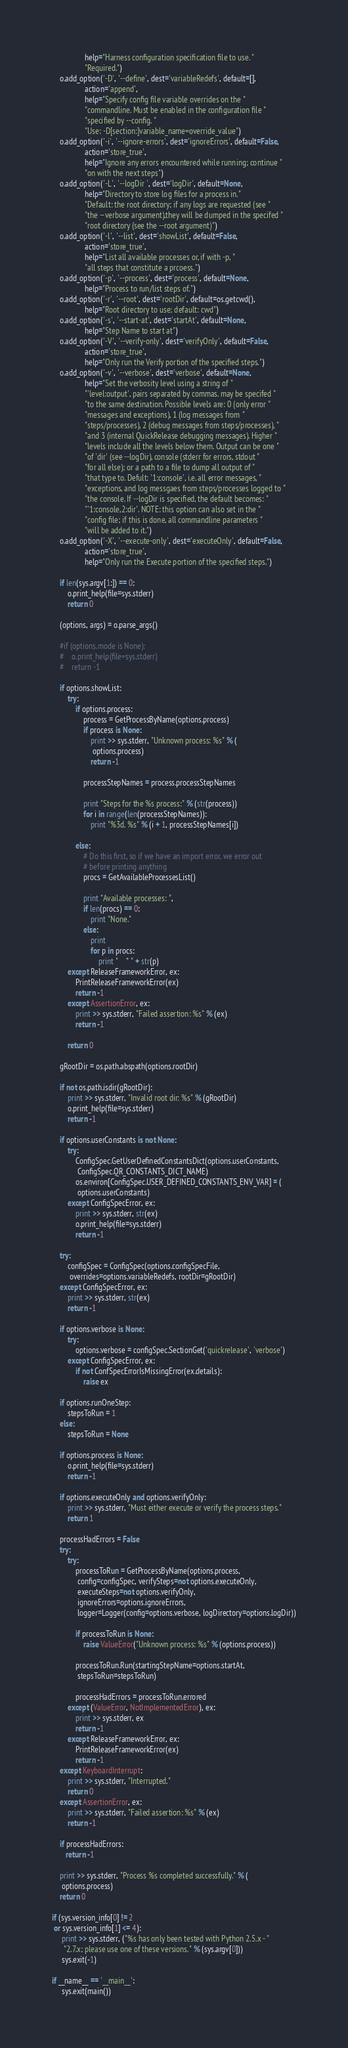Convert code to text. <code><loc_0><loc_0><loc_500><loc_500><_Python_>                 help="Harness configuration specification file to use. "
                 "Required.")
    o.add_option('-D', '--define', dest='variableRedefs', default=[],
                 action='append',
                 help="Specify config file variable overrides on the "
                 "commandline. Must be enabled in the configuration file "
                 "specified by --config. "
                 "Use: -D[section:]variable_name=override_value")
    o.add_option('-i', '--ignore-errors', dest='ignoreErrors', default=False,
                 action='store_true',
                 help="Ignore any errors encountered while running; continue "
                 "on with the next steps")
    o.add_option('-L', '--logDir ', dest='logDir', default=None,
                 help="Directory to store log files for a process in."
                 "Default: the root directory; if any logs are requested (see "
                 "the --verbose argument),they will be dumped in the specifed "
                 "root directory (see the --root argument)")
    o.add_option('-l', '--list', dest='showList', default=False,
                 action='store_true',
                 help="List all available processes or, if with -p, "
                 "all steps that constitute a prcoess.")
    o.add_option('-p', '--process', dest='process', default=None,
                 help="Process to run/list steps of.")
    o.add_option('-r', '--root', dest='rootDir', default=os.getcwd(),
                 help="Root directory to use; default: cwd")
    o.add_option('-s', '--start-at', dest='startAt', default=None,
                 help="Step Name to start at")
    o.add_option('-V', '--verify-only', dest='verifyOnly', default=False,
                 action='store_true',
                 help="Only run the Verify portion of the specified steps.")
    o.add_option('-v', '--verbose', dest='verbose', default=None,
                 help="Set the verbosity level using a string of "
                 "'level:output', pairs separated by commas. may be specifed "
                 "to the same destination. Possible levels are: 0 (only error "
                 "messages and exceptions), 1 (log messages from "
                 "steps/processes), 2 (debug messages from steps/processes), "
                 "and 3 (internal QuickRelease debugging messages). Higher "
                 "levels include all the levels below them. Output can be one "
                 "of 'dir' (see --logDir), console (stderr for errors, stdout "
                 "for all else); or a path to a file to dump all output of "
                 "that type to. Defult: '1:console', i.e. all error messages, "
                 "exceptions, and log messgaes from steps/processes logged to "
                 "the console. If --logDir is specified, the default becomes: "
                 "'1:console,2:dir'. NOTE: this option can also set in the "
                 "config file; if this is done, all commandline parameters "
                 "will be added to it.")
    o.add_option('-X', '--execute-only', dest='executeOnly', default=False,
                 action='store_true',
                 help="Only run the Execute portion of the specified steps.")

    if len(sys.argv[1:]) == 0:
        o.print_help(file=sys.stderr)
        return 0

    (options, args) = o.parse_args()

    #if (options.mode is None):
    #    o.print_help(file=sys.stderr)
    #    return -1

    if options.showList:
        try:
            if options.process:
                process = GetProcessByName(options.process)
                if process is None:
                    print >> sys.stderr, "Unknown process: %s" % (
                     options.process)
                    return -1

                processStepNames = process.processStepNames

                print "Steps for the %s process:" % (str(process))
                for i in range(len(processStepNames)):
                    print "%3d. %s" % (i + 1, processStepNames[i])

            else:
                # Do this first, so if we have an import error, we error out
                # before printing anything
                procs = GetAvailableProcessesList()

                print "Available processes: ",
                if len(procs) == 0:
                    print "None."
                else:
                    print
                    for p in procs:
                        print "    * " + str(p)
        except ReleaseFrameworkError, ex:
            PrintReleaseFrameworkError(ex)
            return -1
        except AssertionError, ex:
            print >> sys.stderr, "Failed assertion: %s" % (ex)
            return -1

        return 0

    gRootDir = os.path.abspath(options.rootDir)

    if not os.path.isdir(gRootDir):
        print >> sys.stderr, "Invalid root dir: %s" % (gRootDir)
        o.print_help(file=sys.stderr)
        return -1

    if options.userConstants is not None:
        try:
            ConfigSpec.GetUserDefinedConstantsDict(options.userConstants,
             ConfigSpec.QR_CONSTANTS_DICT_NAME)
            os.environ[ConfigSpec.USER_DEFINED_CONSTANTS_ENV_VAR] = (
             options.userConstants)
        except ConfigSpecError, ex:
            print >> sys.stderr, str(ex)
            o.print_help(file=sys.stderr)
            return -1

    try:
        configSpec = ConfigSpec(options.configSpecFile,
         overrides=options.variableRedefs, rootDir=gRootDir)
    except ConfigSpecError, ex:
        print >> sys.stderr, str(ex)
        return -1

    if options.verbose is None:
        try:
            options.verbose = configSpec.SectionGet('quickrelease', 'verbose')
        except ConfigSpecError, ex:
            if not ConfSpecErrorIsMissingError(ex.details):
                raise ex

    if options.runOneStep:
        stepsToRun = 1
    else:
        stepsToRun = None

    if options.process is None:
        o.print_help(file=sys.stderr)
        return -1

    if options.executeOnly and options.verifyOnly:
        print >> sys.stderr, "Must either execute or verify the process steps."
        return 1

    processHadErrors = False
    try:
        try:
            processToRun = GetProcessByName(options.process,
             config=configSpec, verifySteps=not options.executeOnly,
             executeSteps=not options.verifyOnly,
             ignoreErrors=options.ignoreErrors,
             logger=Logger(config=options.verbose, logDirectory=options.logDir))

            if processToRun is None:
                raise ValueError("Unknown process: %s" % (options.process))

            processToRun.Run(startingStepName=options.startAt,
             stepsToRun=stepsToRun)

            processHadErrors = processToRun.errored
        except (ValueError, NotImplementedError), ex:
            print >> sys.stderr, ex
            return -1
        except ReleaseFrameworkError, ex:
            PrintReleaseFrameworkError(ex)
            return -1
    except KeyboardInterrupt:
        print >> sys.stderr, "Interrupted."
        return 0
    except AssertionError, ex:
        print >> sys.stderr, "Failed assertion: %s" % (ex)
        return -1

    if processHadErrors:
       return -1 

    print >> sys.stderr, "Process %s completed successfully." % (
     options.process)
    return 0

if (sys.version_info[0] != 2 
 or sys.version_info[1] <= 4):
     print >> sys.stderr, ("%s has only been tested with Python 2.5.x - "
      "2.7.x; please use one of these versions." % (sys.argv[0]))
     sys.exit(-1)

if __name__ == '__main__':
     sys.exit(main())
</code> 